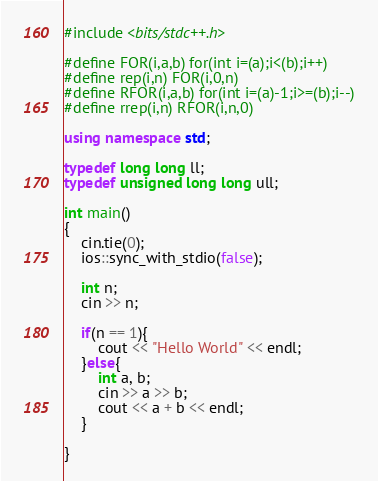<code> <loc_0><loc_0><loc_500><loc_500><_C++_>#include <bits/stdc++.h>

#define FOR(i,a,b) for(int i=(a);i<(b);i++)
#define rep(i,n) FOR(i,0,n)
#define RFOR(i,a,b) for(int i=(a)-1;i>=(b);i--)
#define rrep(i,n) RFOR(i,n,0)

using namespace std;

typedef long long ll;
typedef unsigned long long ull;

int main()
{
	cin.tie(0);
	ios::sync_with_stdio(false);

	int n;
	cin >> n;

	if(n == 1){
		cout << "Hello World" << endl;
	}else{
		int a, b;
		cin >> a >> b;
		cout << a + b << endl;
	}

}
</code> 